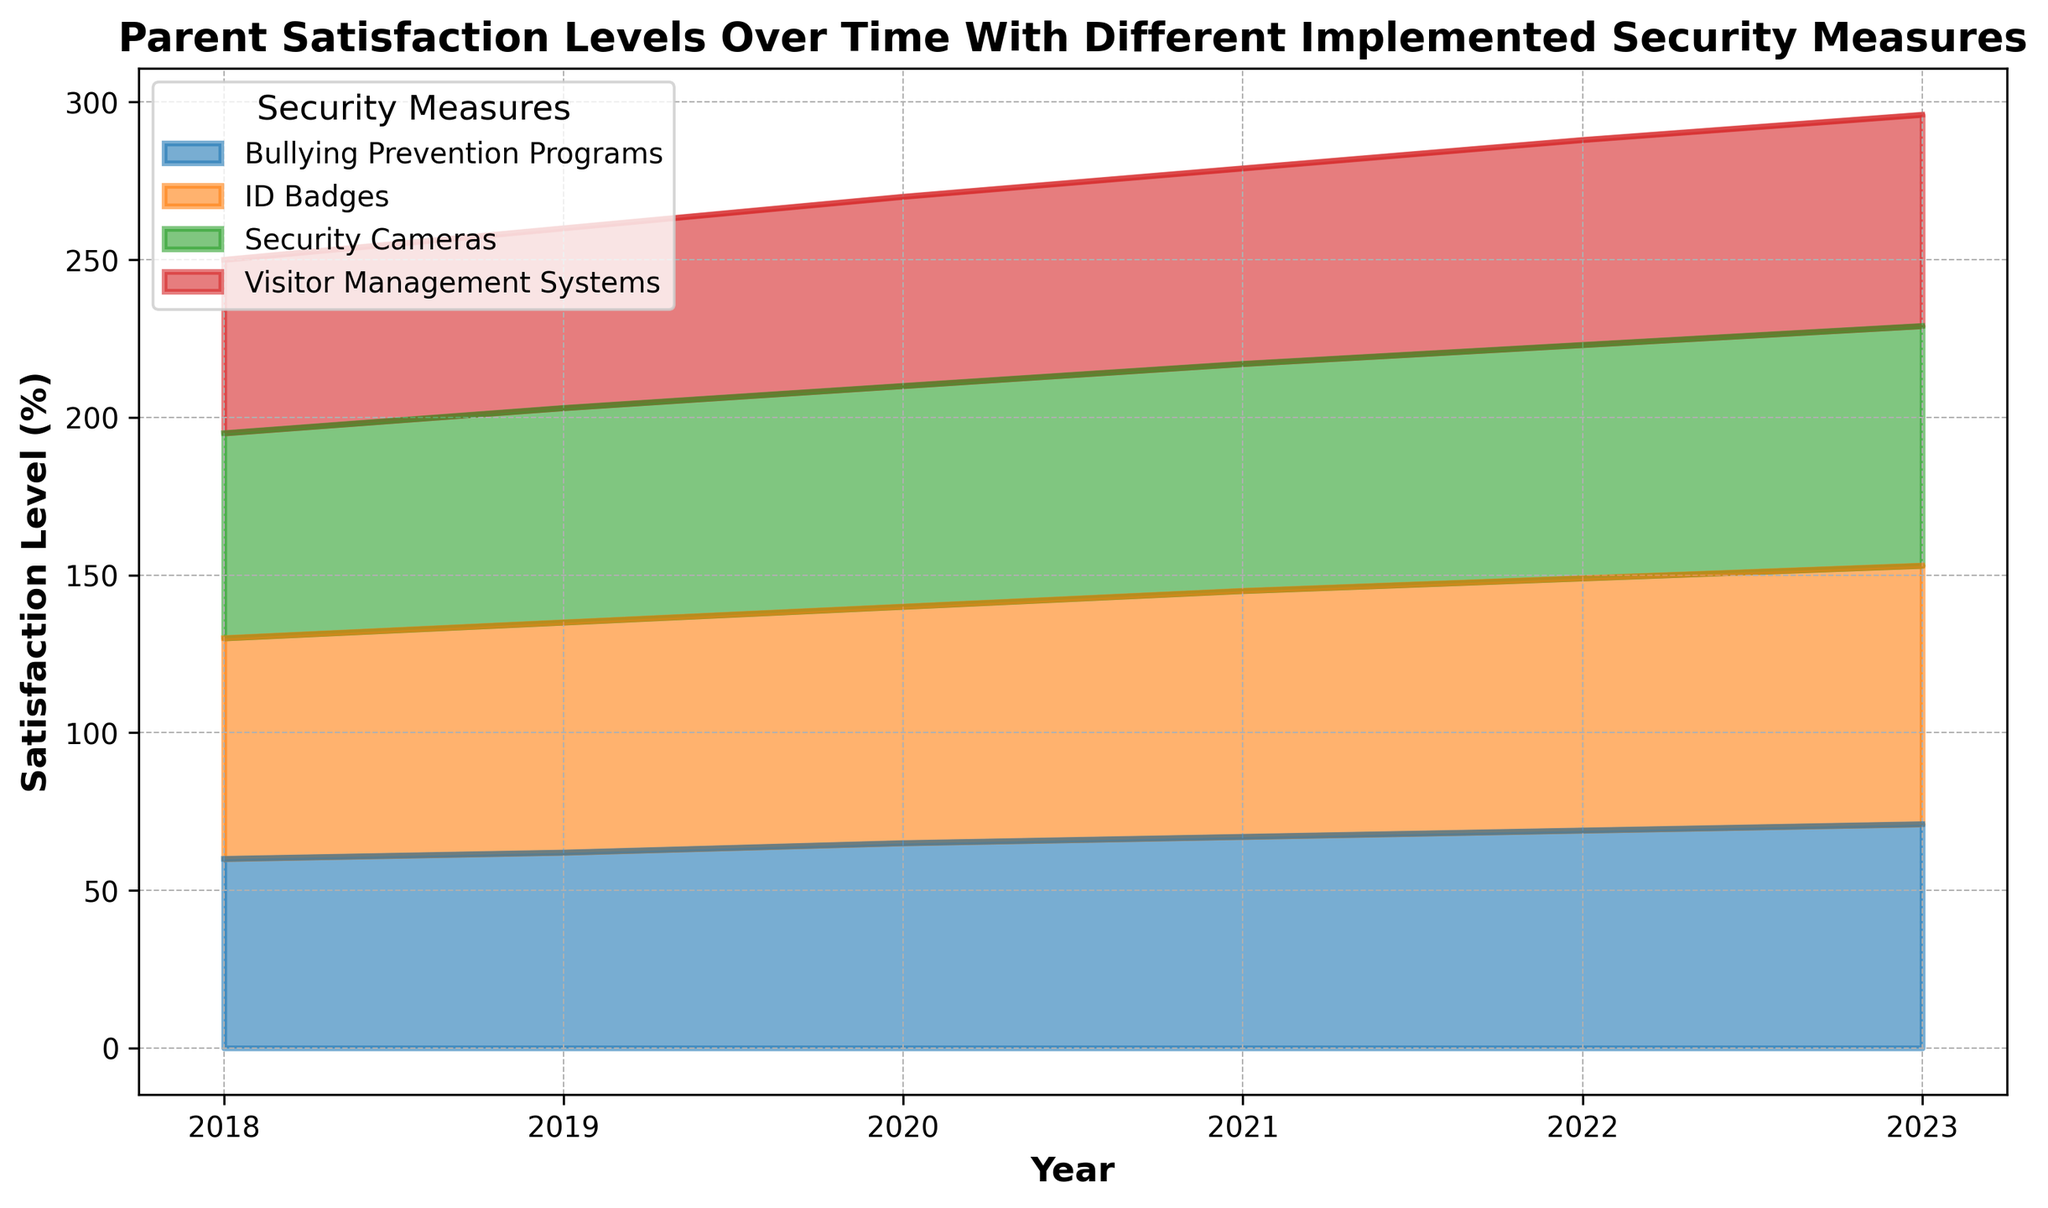What year has the highest overall parent satisfaction level for Security Cameras? We look at the area corresponding to Security Cameras and identify the highest point visually. According to the figure, the highest point occurs in 2023.
Answer: 2023 Which security measure had the least improvement in parent satisfaction from 2018 to 2023? We calculate the increase in satisfaction levels for each measure from 2018 to 2023 by subtracting the 2018 value from the 2023 value for each measure. Visitor Management Systems increased from 55 to 67, a difference of 12 points, which is the smallest increase.
Answer: Visitor Management Systems How did parent satisfaction for ID Badges compare to Security Cameras in 2020? By comparing the height of the areas for ID Badges and Security Cameras in 2020, we see that satisfaction for ID Badges was higher. Specifically, ID Badges had a satisfaction of 75%, while Security Cameras had 70%.
Answer: ID Badges had higher satisfaction What is the total increase in parent satisfaction for Bullying Prevention Programs from 2018 to 2023? We identify the values for Bullying Prevention Programs in 2018 and 2023 and calculate the difference: 71 (in 2023) - 60 (in 2018) = 11.
Answer: 11 Between 2019 and 2020, which measure saw the largest increase in satisfaction? We calculate the yearly increase for each measure by subtracting 2019 values from 2020 values. Security Cameras increased by 2 (70 - 68), ID Badges by 2 (75 - 73), Bullying Prevention Programs by 3 (65 - 62), and Visitor Management Systems by 3 (60 - 57). Two measures, Bullying Prevention Programs and Visitor Management Systems, saw the largest increase, both by 3.
Answer: Bullying Prevention Programs and Visitor Management Systems What year did Visitor Management Systems reach a satisfaction level of 60? We look for the point where Visitor Management Systems' area first reaches a value of 60. According to the trend, this happens in 2020.
Answer: 2020 Compare the trends for ID Badges and Security Cameras from 2018 to 2023. Which measure consistently had higher satisfaction? By comparing the areas over time, we see that ID Badges consistently had higher satisfaction levels than Security Cameras from 2018 to 2023.
Answer: ID Badges What was the average parent satisfaction level for all measures in 2021? We calculate the average value of the four measures in 2021: (72 + 78 + 67 + 62) / 4 = 279 / 4 = 69.75.
Answer: 69.75 